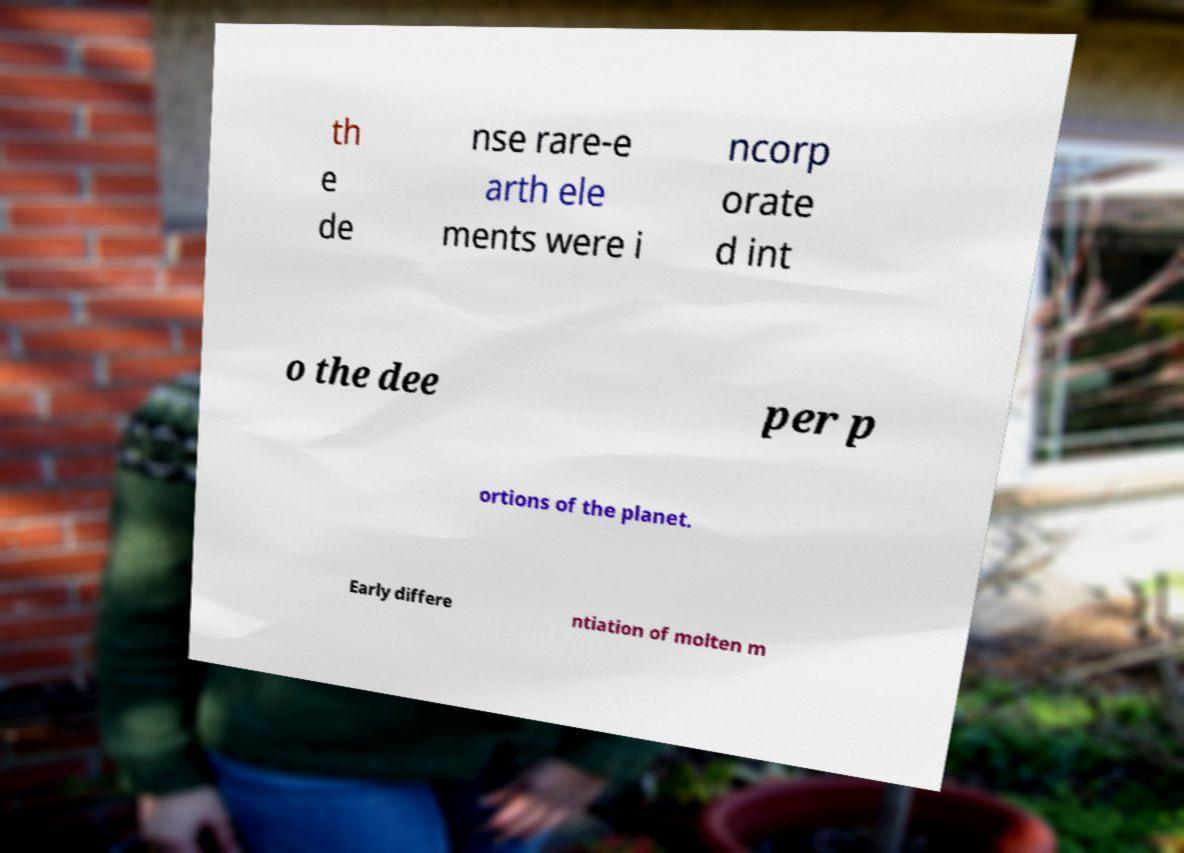For documentation purposes, I need the text within this image transcribed. Could you provide that? th e de nse rare-e arth ele ments were i ncorp orate d int o the dee per p ortions of the planet. Early differe ntiation of molten m 